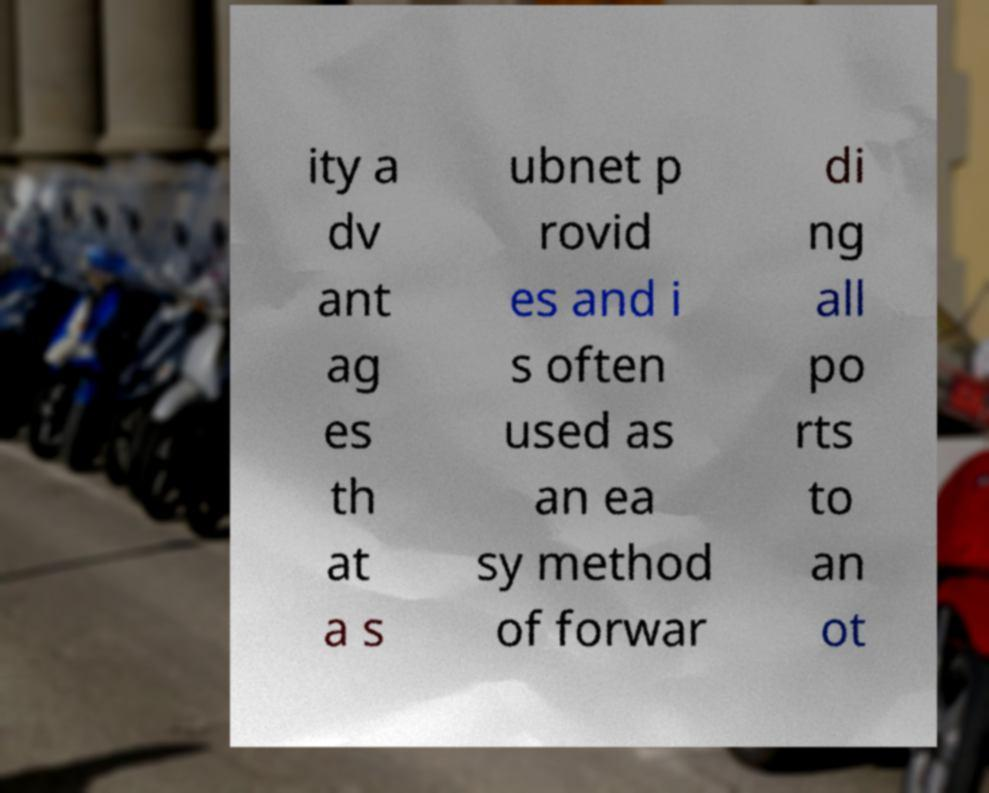For documentation purposes, I need the text within this image transcribed. Could you provide that? ity a dv ant ag es th at a s ubnet p rovid es and i s often used as an ea sy method of forwar di ng all po rts to an ot 